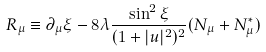Convert formula to latex. <formula><loc_0><loc_0><loc_500><loc_500>R _ { \mu } \equiv \partial _ { \mu } \xi - 8 \lambda \frac { \sin ^ { 2 } \xi } { ( 1 + | u | ^ { 2 } ) ^ { 2 } } ( N _ { \mu } + N _ { \mu } ^ { * } )</formula> 